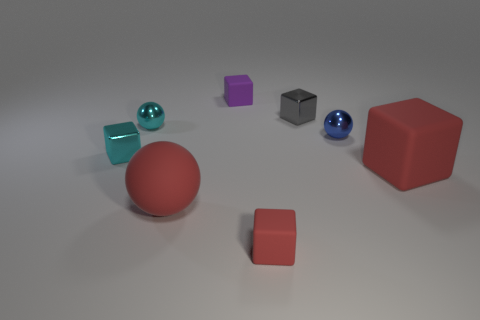Subtract 2 blocks. How many blocks are left? 3 Subtract all large red rubber cubes. How many cubes are left? 4 Subtract all cyan cubes. How many cubes are left? 4 Subtract all green blocks. Subtract all yellow spheres. How many blocks are left? 5 Add 1 small cyan metal blocks. How many objects exist? 9 Subtract all spheres. How many objects are left? 5 Subtract 0 gray balls. How many objects are left? 8 Subtract all tiny shiny cylinders. Subtract all small purple things. How many objects are left? 7 Add 4 big blocks. How many big blocks are left? 5 Add 2 small cyan balls. How many small cyan balls exist? 3 